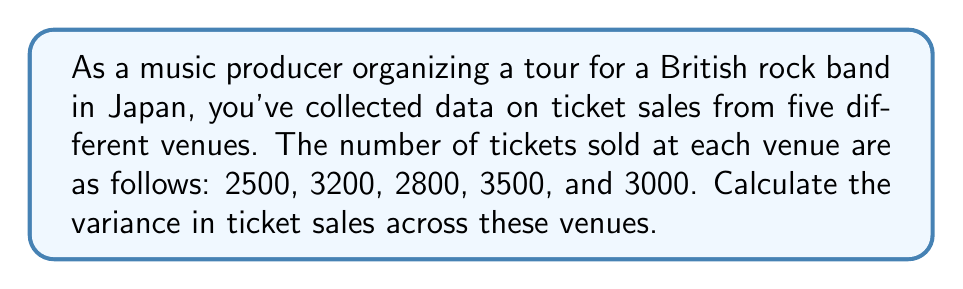Show me your answer to this math problem. To calculate the variance, we'll follow these steps:

1. Calculate the mean (average) of the ticket sales:
   $$\mu = \frac{2500 + 3200 + 2800 + 3500 + 3000}{5} = 3000$$

2. Calculate the squared differences from the mean for each value:
   $$(2500 - 3000)^2 = (-500)^2 = 250000$$
   $$(3200 - 3000)^2 = (200)^2 = 40000$$
   $$(2800 - 3000)^2 = (-200)^2 = 40000$$
   $$(3500 - 3000)^2 = (500)^2 = 250000$$
   $$(3000 - 3000)^2 = (0)^2 = 0$$

3. Sum the squared differences:
   $$250000 + 40000 + 40000 + 250000 + 0 = 580000$$

4. Divide the sum by the number of venues (n = 5) to get the variance:
   $$\text{Variance} = \frac{580000}{5} = 116000$$

The formula for variance is:
$$\sigma^2 = \frac{\sum_{i=1}^{n} (x_i - \mu)^2}{n}$$

Where:
$\sigma^2$ is the variance
$x_i$ are the individual values
$\mu$ is the mean
$n$ is the number of values
Answer: The variance in ticket sales across the five venues is 116000. 